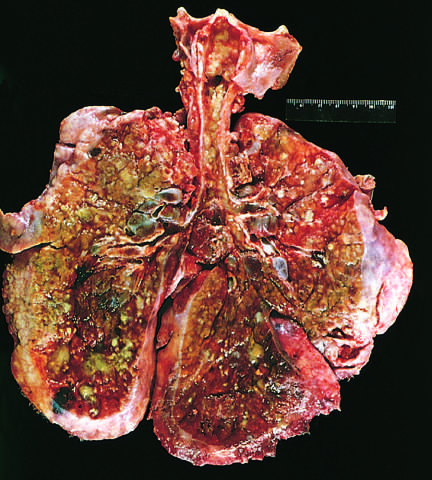s the pulmonary parenchyma consolidated by a combination of both secretions and pneumonia?
Answer the question using a single word or phrase. Yes 